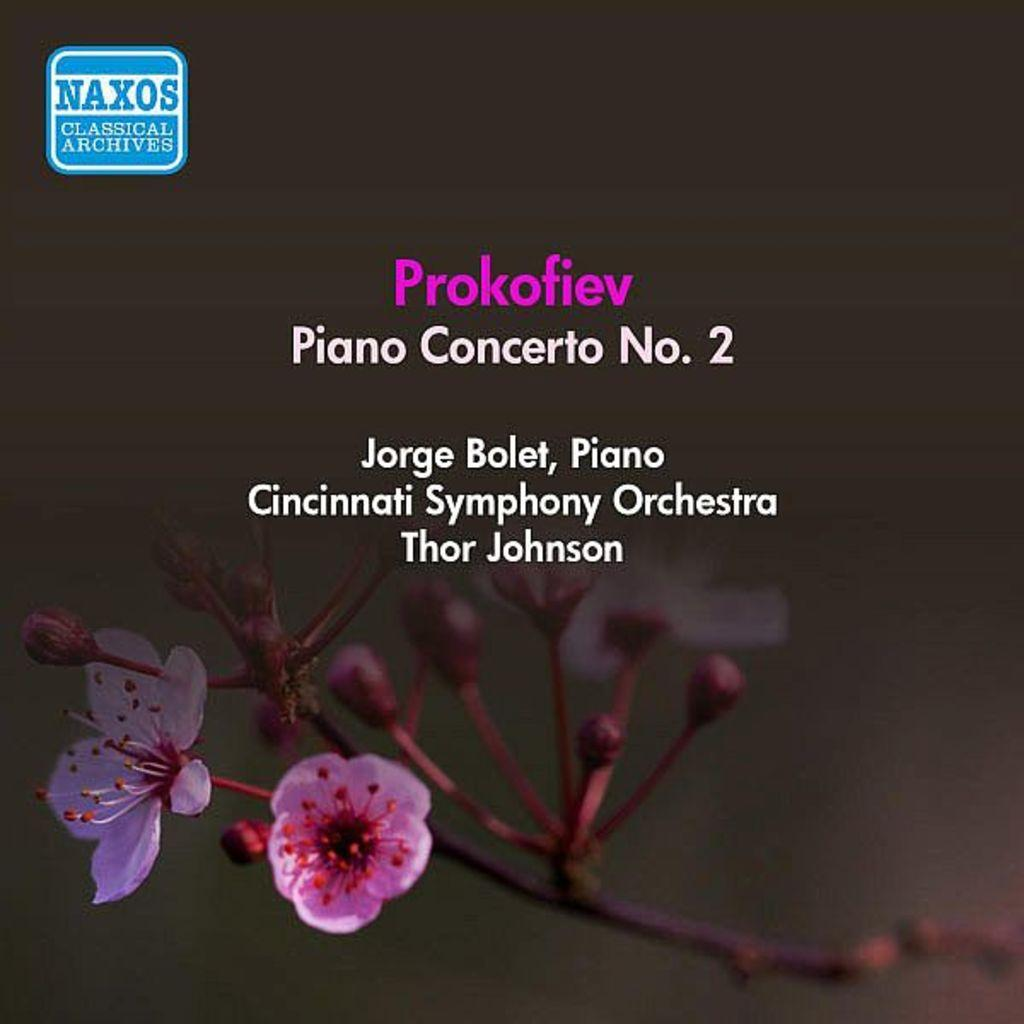Provide a one-sentence caption for the provided image. A page showing the Piano concerto No, 2 is being performed at the Cincinatti symphony. 